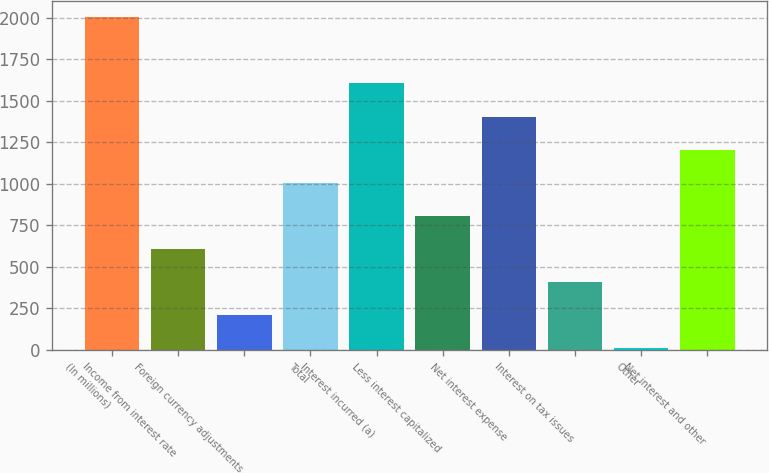Convert chart. <chart><loc_0><loc_0><loc_500><loc_500><bar_chart><fcel>(In millions)<fcel>Income from interest rate<fcel>Foreign currency adjustments<fcel>Total<fcel>Interest incurred (a)<fcel>Less interest capitalized<fcel>Net interest expense<fcel>Interest on tax issues<fcel>Other<fcel>Net interest and other<nl><fcel>2003<fcel>607.9<fcel>209.3<fcel>1006.5<fcel>1604.4<fcel>807.2<fcel>1405.1<fcel>408.6<fcel>10<fcel>1205.8<nl></chart> 